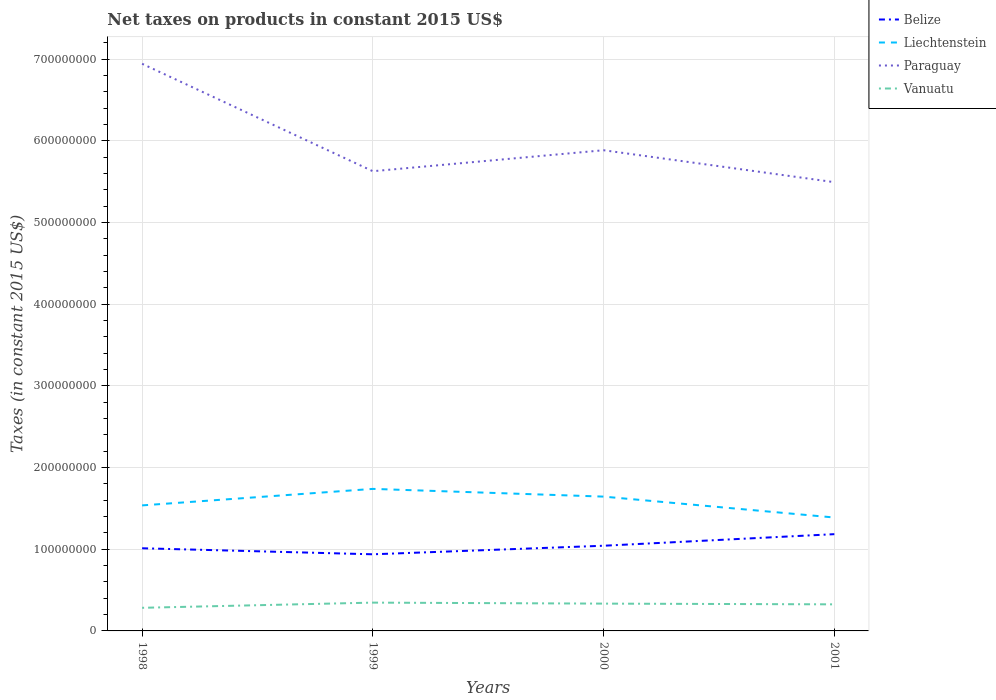How many different coloured lines are there?
Your response must be concise. 4. Is the number of lines equal to the number of legend labels?
Your response must be concise. Yes. Across all years, what is the maximum net taxes on products in Liechtenstein?
Your response must be concise. 1.39e+08. What is the total net taxes on products in Liechtenstein in the graph?
Ensure brevity in your answer.  -1.08e+07. What is the difference between the highest and the second highest net taxes on products in Paraguay?
Keep it short and to the point. 1.45e+08. Are the values on the major ticks of Y-axis written in scientific E-notation?
Keep it short and to the point. No. Does the graph contain any zero values?
Offer a very short reply. No. Where does the legend appear in the graph?
Your answer should be compact. Top right. How many legend labels are there?
Offer a very short reply. 4. How are the legend labels stacked?
Offer a very short reply. Vertical. What is the title of the graph?
Your answer should be very brief. Net taxes on products in constant 2015 US$. What is the label or title of the Y-axis?
Your answer should be compact. Taxes (in constant 2015 US$). What is the Taxes (in constant 2015 US$) in Belize in 1998?
Provide a succinct answer. 1.01e+08. What is the Taxes (in constant 2015 US$) of Liechtenstein in 1998?
Ensure brevity in your answer.  1.54e+08. What is the Taxes (in constant 2015 US$) in Paraguay in 1998?
Your answer should be compact. 6.94e+08. What is the Taxes (in constant 2015 US$) of Vanuatu in 1998?
Provide a short and direct response. 2.83e+07. What is the Taxes (in constant 2015 US$) of Belize in 1999?
Offer a very short reply. 9.38e+07. What is the Taxes (in constant 2015 US$) of Liechtenstein in 1999?
Offer a terse response. 1.74e+08. What is the Taxes (in constant 2015 US$) of Paraguay in 1999?
Provide a short and direct response. 5.63e+08. What is the Taxes (in constant 2015 US$) in Vanuatu in 1999?
Offer a terse response. 3.46e+07. What is the Taxes (in constant 2015 US$) of Belize in 2000?
Give a very brief answer. 1.04e+08. What is the Taxes (in constant 2015 US$) of Liechtenstein in 2000?
Provide a succinct answer. 1.64e+08. What is the Taxes (in constant 2015 US$) of Paraguay in 2000?
Your answer should be very brief. 5.88e+08. What is the Taxes (in constant 2015 US$) in Vanuatu in 2000?
Keep it short and to the point. 3.34e+07. What is the Taxes (in constant 2015 US$) of Belize in 2001?
Provide a short and direct response. 1.18e+08. What is the Taxes (in constant 2015 US$) of Liechtenstein in 2001?
Give a very brief answer. 1.39e+08. What is the Taxes (in constant 2015 US$) in Paraguay in 2001?
Offer a very short reply. 5.49e+08. What is the Taxes (in constant 2015 US$) in Vanuatu in 2001?
Your response must be concise. 3.25e+07. Across all years, what is the maximum Taxes (in constant 2015 US$) in Belize?
Offer a very short reply. 1.18e+08. Across all years, what is the maximum Taxes (in constant 2015 US$) in Liechtenstein?
Your answer should be very brief. 1.74e+08. Across all years, what is the maximum Taxes (in constant 2015 US$) in Paraguay?
Provide a short and direct response. 6.94e+08. Across all years, what is the maximum Taxes (in constant 2015 US$) in Vanuatu?
Provide a short and direct response. 3.46e+07. Across all years, what is the minimum Taxes (in constant 2015 US$) in Belize?
Provide a succinct answer. 9.38e+07. Across all years, what is the minimum Taxes (in constant 2015 US$) of Liechtenstein?
Your response must be concise. 1.39e+08. Across all years, what is the minimum Taxes (in constant 2015 US$) in Paraguay?
Your answer should be compact. 5.49e+08. Across all years, what is the minimum Taxes (in constant 2015 US$) of Vanuatu?
Your answer should be compact. 2.83e+07. What is the total Taxes (in constant 2015 US$) in Belize in the graph?
Provide a short and direct response. 4.18e+08. What is the total Taxes (in constant 2015 US$) in Liechtenstein in the graph?
Make the answer very short. 6.31e+08. What is the total Taxes (in constant 2015 US$) of Paraguay in the graph?
Keep it short and to the point. 2.39e+09. What is the total Taxes (in constant 2015 US$) in Vanuatu in the graph?
Your answer should be very brief. 1.29e+08. What is the difference between the Taxes (in constant 2015 US$) of Belize in 1998 and that in 1999?
Offer a very short reply. 7.38e+06. What is the difference between the Taxes (in constant 2015 US$) of Liechtenstein in 1998 and that in 1999?
Give a very brief answer. -2.02e+07. What is the difference between the Taxes (in constant 2015 US$) in Paraguay in 1998 and that in 1999?
Your answer should be very brief. 1.32e+08. What is the difference between the Taxes (in constant 2015 US$) in Vanuatu in 1998 and that in 1999?
Keep it short and to the point. -6.34e+06. What is the difference between the Taxes (in constant 2015 US$) of Belize in 1998 and that in 2000?
Offer a terse response. -3.10e+06. What is the difference between the Taxes (in constant 2015 US$) in Liechtenstein in 1998 and that in 2000?
Your response must be concise. -1.08e+07. What is the difference between the Taxes (in constant 2015 US$) in Paraguay in 1998 and that in 2000?
Your response must be concise. 1.06e+08. What is the difference between the Taxes (in constant 2015 US$) of Vanuatu in 1998 and that in 2000?
Give a very brief answer. -5.12e+06. What is the difference between the Taxes (in constant 2015 US$) of Belize in 1998 and that in 2001?
Make the answer very short. -1.73e+07. What is the difference between the Taxes (in constant 2015 US$) of Liechtenstein in 1998 and that in 2001?
Provide a short and direct response. 1.48e+07. What is the difference between the Taxes (in constant 2015 US$) in Paraguay in 1998 and that in 2001?
Give a very brief answer. 1.45e+08. What is the difference between the Taxes (in constant 2015 US$) in Vanuatu in 1998 and that in 2001?
Make the answer very short. -4.23e+06. What is the difference between the Taxes (in constant 2015 US$) in Belize in 1999 and that in 2000?
Provide a succinct answer. -1.05e+07. What is the difference between the Taxes (in constant 2015 US$) in Liechtenstein in 1999 and that in 2000?
Make the answer very short. 9.45e+06. What is the difference between the Taxes (in constant 2015 US$) in Paraguay in 1999 and that in 2000?
Your answer should be compact. -2.57e+07. What is the difference between the Taxes (in constant 2015 US$) of Vanuatu in 1999 and that in 2000?
Make the answer very short. 1.22e+06. What is the difference between the Taxes (in constant 2015 US$) of Belize in 1999 and that in 2001?
Offer a terse response. -2.46e+07. What is the difference between the Taxes (in constant 2015 US$) in Liechtenstein in 1999 and that in 2001?
Your response must be concise. 3.50e+07. What is the difference between the Taxes (in constant 2015 US$) of Paraguay in 1999 and that in 2001?
Keep it short and to the point. 1.34e+07. What is the difference between the Taxes (in constant 2015 US$) of Vanuatu in 1999 and that in 2001?
Keep it short and to the point. 2.12e+06. What is the difference between the Taxes (in constant 2015 US$) of Belize in 2000 and that in 2001?
Provide a succinct answer. -1.42e+07. What is the difference between the Taxes (in constant 2015 US$) of Liechtenstein in 2000 and that in 2001?
Ensure brevity in your answer.  2.56e+07. What is the difference between the Taxes (in constant 2015 US$) in Paraguay in 2000 and that in 2001?
Provide a short and direct response. 3.91e+07. What is the difference between the Taxes (in constant 2015 US$) in Vanuatu in 2000 and that in 2001?
Provide a succinct answer. 8.97e+05. What is the difference between the Taxes (in constant 2015 US$) in Belize in 1998 and the Taxes (in constant 2015 US$) in Liechtenstein in 1999?
Your response must be concise. -7.27e+07. What is the difference between the Taxes (in constant 2015 US$) of Belize in 1998 and the Taxes (in constant 2015 US$) of Paraguay in 1999?
Your response must be concise. -4.62e+08. What is the difference between the Taxes (in constant 2015 US$) in Belize in 1998 and the Taxes (in constant 2015 US$) in Vanuatu in 1999?
Ensure brevity in your answer.  6.65e+07. What is the difference between the Taxes (in constant 2015 US$) in Liechtenstein in 1998 and the Taxes (in constant 2015 US$) in Paraguay in 1999?
Keep it short and to the point. -4.09e+08. What is the difference between the Taxes (in constant 2015 US$) of Liechtenstein in 1998 and the Taxes (in constant 2015 US$) of Vanuatu in 1999?
Keep it short and to the point. 1.19e+08. What is the difference between the Taxes (in constant 2015 US$) of Paraguay in 1998 and the Taxes (in constant 2015 US$) of Vanuatu in 1999?
Provide a succinct answer. 6.60e+08. What is the difference between the Taxes (in constant 2015 US$) in Belize in 1998 and the Taxes (in constant 2015 US$) in Liechtenstein in 2000?
Offer a very short reply. -6.32e+07. What is the difference between the Taxes (in constant 2015 US$) of Belize in 1998 and the Taxes (in constant 2015 US$) of Paraguay in 2000?
Ensure brevity in your answer.  -4.87e+08. What is the difference between the Taxes (in constant 2015 US$) of Belize in 1998 and the Taxes (in constant 2015 US$) of Vanuatu in 2000?
Make the answer very short. 6.78e+07. What is the difference between the Taxes (in constant 2015 US$) of Liechtenstein in 1998 and the Taxes (in constant 2015 US$) of Paraguay in 2000?
Your response must be concise. -4.35e+08. What is the difference between the Taxes (in constant 2015 US$) of Liechtenstein in 1998 and the Taxes (in constant 2015 US$) of Vanuatu in 2000?
Your response must be concise. 1.20e+08. What is the difference between the Taxes (in constant 2015 US$) in Paraguay in 1998 and the Taxes (in constant 2015 US$) in Vanuatu in 2000?
Ensure brevity in your answer.  6.61e+08. What is the difference between the Taxes (in constant 2015 US$) in Belize in 1998 and the Taxes (in constant 2015 US$) in Liechtenstein in 2001?
Offer a terse response. -3.76e+07. What is the difference between the Taxes (in constant 2015 US$) in Belize in 1998 and the Taxes (in constant 2015 US$) in Paraguay in 2001?
Your answer should be very brief. -4.48e+08. What is the difference between the Taxes (in constant 2015 US$) of Belize in 1998 and the Taxes (in constant 2015 US$) of Vanuatu in 2001?
Ensure brevity in your answer.  6.87e+07. What is the difference between the Taxes (in constant 2015 US$) of Liechtenstein in 1998 and the Taxes (in constant 2015 US$) of Paraguay in 2001?
Your response must be concise. -3.96e+08. What is the difference between the Taxes (in constant 2015 US$) of Liechtenstein in 1998 and the Taxes (in constant 2015 US$) of Vanuatu in 2001?
Provide a short and direct response. 1.21e+08. What is the difference between the Taxes (in constant 2015 US$) in Paraguay in 1998 and the Taxes (in constant 2015 US$) in Vanuatu in 2001?
Your answer should be very brief. 6.62e+08. What is the difference between the Taxes (in constant 2015 US$) of Belize in 1999 and the Taxes (in constant 2015 US$) of Liechtenstein in 2000?
Your answer should be very brief. -7.06e+07. What is the difference between the Taxes (in constant 2015 US$) in Belize in 1999 and the Taxes (in constant 2015 US$) in Paraguay in 2000?
Offer a terse response. -4.95e+08. What is the difference between the Taxes (in constant 2015 US$) in Belize in 1999 and the Taxes (in constant 2015 US$) in Vanuatu in 2000?
Make the answer very short. 6.04e+07. What is the difference between the Taxes (in constant 2015 US$) in Liechtenstein in 1999 and the Taxes (in constant 2015 US$) in Paraguay in 2000?
Ensure brevity in your answer.  -4.15e+08. What is the difference between the Taxes (in constant 2015 US$) in Liechtenstein in 1999 and the Taxes (in constant 2015 US$) in Vanuatu in 2000?
Provide a short and direct response. 1.40e+08. What is the difference between the Taxes (in constant 2015 US$) in Paraguay in 1999 and the Taxes (in constant 2015 US$) in Vanuatu in 2000?
Provide a short and direct response. 5.29e+08. What is the difference between the Taxes (in constant 2015 US$) in Belize in 1999 and the Taxes (in constant 2015 US$) in Liechtenstein in 2001?
Keep it short and to the point. -4.50e+07. What is the difference between the Taxes (in constant 2015 US$) in Belize in 1999 and the Taxes (in constant 2015 US$) in Paraguay in 2001?
Keep it short and to the point. -4.56e+08. What is the difference between the Taxes (in constant 2015 US$) of Belize in 1999 and the Taxes (in constant 2015 US$) of Vanuatu in 2001?
Keep it short and to the point. 6.13e+07. What is the difference between the Taxes (in constant 2015 US$) of Liechtenstein in 1999 and the Taxes (in constant 2015 US$) of Paraguay in 2001?
Give a very brief answer. -3.75e+08. What is the difference between the Taxes (in constant 2015 US$) of Liechtenstein in 1999 and the Taxes (in constant 2015 US$) of Vanuatu in 2001?
Your answer should be very brief. 1.41e+08. What is the difference between the Taxes (in constant 2015 US$) in Paraguay in 1999 and the Taxes (in constant 2015 US$) in Vanuatu in 2001?
Make the answer very short. 5.30e+08. What is the difference between the Taxes (in constant 2015 US$) of Belize in 2000 and the Taxes (in constant 2015 US$) of Liechtenstein in 2001?
Ensure brevity in your answer.  -3.45e+07. What is the difference between the Taxes (in constant 2015 US$) in Belize in 2000 and the Taxes (in constant 2015 US$) in Paraguay in 2001?
Give a very brief answer. -4.45e+08. What is the difference between the Taxes (in constant 2015 US$) of Belize in 2000 and the Taxes (in constant 2015 US$) of Vanuatu in 2001?
Ensure brevity in your answer.  7.18e+07. What is the difference between the Taxes (in constant 2015 US$) of Liechtenstein in 2000 and the Taxes (in constant 2015 US$) of Paraguay in 2001?
Your response must be concise. -3.85e+08. What is the difference between the Taxes (in constant 2015 US$) of Liechtenstein in 2000 and the Taxes (in constant 2015 US$) of Vanuatu in 2001?
Keep it short and to the point. 1.32e+08. What is the difference between the Taxes (in constant 2015 US$) of Paraguay in 2000 and the Taxes (in constant 2015 US$) of Vanuatu in 2001?
Your response must be concise. 5.56e+08. What is the average Taxes (in constant 2015 US$) of Belize per year?
Ensure brevity in your answer.  1.04e+08. What is the average Taxes (in constant 2015 US$) in Liechtenstein per year?
Provide a succinct answer. 1.58e+08. What is the average Taxes (in constant 2015 US$) of Paraguay per year?
Provide a succinct answer. 5.99e+08. What is the average Taxes (in constant 2015 US$) in Vanuatu per year?
Give a very brief answer. 3.22e+07. In the year 1998, what is the difference between the Taxes (in constant 2015 US$) in Belize and Taxes (in constant 2015 US$) in Liechtenstein?
Offer a very short reply. -5.25e+07. In the year 1998, what is the difference between the Taxes (in constant 2015 US$) in Belize and Taxes (in constant 2015 US$) in Paraguay?
Your answer should be compact. -5.93e+08. In the year 1998, what is the difference between the Taxes (in constant 2015 US$) in Belize and Taxes (in constant 2015 US$) in Vanuatu?
Give a very brief answer. 7.29e+07. In the year 1998, what is the difference between the Taxes (in constant 2015 US$) of Liechtenstein and Taxes (in constant 2015 US$) of Paraguay?
Provide a succinct answer. -5.41e+08. In the year 1998, what is the difference between the Taxes (in constant 2015 US$) of Liechtenstein and Taxes (in constant 2015 US$) of Vanuatu?
Provide a short and direct response. 1.25e+08. In the year 1998, what is the difference between the Taxes (in constant 2015 US$) of Paraguay and Taxes (in constant 2015 US$) of Vanuatu?
Your answer should be compact. 6.66e+08. In the year 1999, what is the difference between the Taxes (in constant 2015 US$) of Belize and Taxes (in constant 2015 US$) of Liechtenstein?
Your answer should be compact. -8.01e+07. In the year 1999, what is the difference between the Taxes (in constant 2015 US$) of Belize and Taxes (in constant 2015 US$) of Paraguay?
Make the answer very short. -4.69e+08. In the year 1999, what is the difference between the Taxes (in constant 2015 US$) in Belize and Taxes (in constant 2015 US$) in Vanuatu?
Your response must be concise. 5.92e+07. In the year 1999, what is the difference between the Taxes (in constant 2015 US$) of Liechtenstein and Taxes (in constant 2015 US$) of Paraguay?
Your answer should be compact. -3.89e+08. In the year 1999, what is the difference between the Taxes (in constant 2015 US$) of Liechtenstein and Taxes (in constant 2015 US$) of Vanuatu?
Offer a very short reply. 1.39e+08. In the year 1999, what is the difference between the Taxes (in constant 2015 US$) in Paraguay and Taxes (in constant 2015 US$) in Vanuatu?
Give a very brief answer. 5.28e+08. In the year 2000, what is the difference between the Taxes (in constant 2015 US$) in Belize and Taxes (in constant 2015 US$) in Liechtenstein?
Ensure brevity in your answer.  -6.01e+07. In the year 2000, what is the difference between the Taxes (in constant 2015 US$) in Belize and Taxes (in constant 2015 US$) in Paraguay?
Offer a terse response. -4.84e+08. In the year 2000, what is the difference between the Taxes (in constant 2015 US$) of Belize and Taxes (in constant 2015 US$) of Vanuatu?
Provide a succinct answer. 7.09e+07. In the year 2000, what is the difference between the Taxes (in constant 2015 US$) in Liechtenstein and Taxes (in constant 2015 US$) in Paraguay?
Keep it short and to the point. -4.24e+08. In the year 2000, what is the difference between the Taxes (in constant 2015 US$) in Liechtenstein and Taxes (in constant 2015 US$) in Vanuatu?
Give a very brief answer. 1.31e+08. In the year 2000, what is the difference between the Taxes (in constant 2015 US$) of Paraguay and Taxes (in constant 2015 US$) of Vanuatu?
Offer a very short reply. 5.55e+08. In the year 2001, what is the difference between the Taxes (in constant 2015 US$) of Belize and Taxes (in constant 2015 US$) of Liechtenstein?
Provide a succinct answer. -2.04e+07. In the year 2001, what is the difference between the Taxes (in constant 2015 US$) in Belize and Taxes (in constant 2015 US$) in Paraguay?
Your answer should be very brief. -4.31e+08. In the year 2001, what is the difference between the Taxes (in constant 2015 US$) of Belize and Taxes (in constant 2015 US$) of Vanuatu?
Offer a terse response. 8.59e+07. In the year 2001, what is the difference between the Taxes (in constant 2015 US$) of Liechtenstein and Taxes (in constant 2015 US$) of Paraguay?
Provide a short and direct response. -4.11e+08. In the year 2001, what is the difference between the Taxes (in constant 2015 US$) of Liechtenstein and Taxes (in constant 2015 US$) of Vanuatu?
Your answer should be compact. 1.06e+08. In the year 2001, what is the difference between the Taxes (in constant 2015 US$) of Paraguay and Taxes (in constant 2015 US$) of Vanuatu?
Your answer should be compact. 5.17e+08. What is the ratio of the Taxes (in constant 2015 US$) of Belize in 1998 to that in 1999?
Keep it short and to the point. 1.08. What is the ratio of the Taxes (in constant 2015 US$) in Liechtenstein in 1998 to that in 1999?
Your answer should be very brief. 0.88. What is the ratio of the Taxes (in constant 2015 US$) of Paraguay in 1998 to that in 1999?
Your answer should be compact. 1.23. What is the ratio of the Taxes (in constant 2015 US$) of Vanuatu in 1998 to that in 1999?
Make the answer very short. 0.82. What is the ratio of the Taxes (in constant 2015 US$) in Belize in 1998 to that in 2000?
Keep it short and to the point. 0.97. What is the ratio of the Taxes (in constant 2015 US$) of Liechtenstein in 1998 to that in 2000?
Make the answer very short. 0.93. What is the ratio of the Taxes (in constant 2015 US$) of Paraguay in 1998 to that in 2000?
Offer a very short reply. 1.18. What is the ratio of the Taxes (in constant 2015 US$) in Vanuatu in 1998 to that in 2000?
Make the answer very short. 0.85. What is the ratio of the Taxes (in constant 2015 US$) in Belize in 1998 to that in 2001?
Your answer should be very brief. 0.85. What is the ratio of the Taxes (in constant 2015 US$) in Liechtenstein in 1998 to that in 2001?
Offer a very short reply. 1.11. What is the ratio of the Taxes (in constant 2015 US$) of Paraguay in 1998 to that in 2001?
Ensure brevity in your answer.  1.26. What is the ratio of the Taxes (in constant 2015 US$) in Vanuatu in 1998 to that in 2001?
Your response must be concise. 0.87. What is the ratio of the Taxes (in constant 2015 US$) in Belize in 1999 to that in 2000?
Make the answer very short. 0.9. What is the ratio of the Taxes (in constant 2015 US$) in Liechtenstein in 1999 to that in 2000?
Ensure brevity in your answer.  1.06. What is the ratio of the Taxes (in constant 2015 US$) in Paraguay in 1999 to that in 2000?
Your response must be concise. 0.96. What is the ratio of the Taxes (in constant 2015 US$) of Vanuatu in 1999 to that in 2000?
Provide a succinct answer. 1.04. What is the ratio of the Taxes (in constant 2015 US$) in Belize in 1999 to that in 2001?
Offer a terse response. 0.79. What is the ratio of the Taxes (in constant 2015 US$) of Liechtenstein in 1999 to that in 2001?
Make the answer very short. 1.25. What is the ratio of the Taxes (in constant 2015 US$) in Paraguay in 1999 to that in 2001?
Provide a succinct answer. 1.02. What is the ratio of the Taxes (in constant 2015 US$) of Vanuatu in 1999 to that in 2001?
Your answer should be compact. 1.07. What is the ratio of the Taxes (in constant 2015 US$) of Belize in 2000 to that in 2001?
Ensure brevity in your answer.  0.88. What is the ratio of the Taxes (in constant 2015 US$) in Liechtenstein in 2000 to that in 2001?
Give a very brief answer. 1.18. What is the ratio of the Taxes (in constant 2015 US$) in Paraguay in 2000 to that in 2001?
Offer a terse response. 1.07. What is the ratio of the Taxes (in constant 2015 US$) in Vanuatu in 2000 to that in 2001?
Provide a succinct answer. 1.03. What is the difference between the highest and the second highest Taxes (in constant 2015 US$) in Belize?
Your response must be concise. 1.42e+07. What is the difference between the highest and the second highest Taxes (in constant 2015 US$) of Liechtenstein?
Offer a very short reply. 9.45e+06. What is the difference between the highest and the second highest Taxes (in constant 2015 US$) in Paraguay?
Keep it short and to the point. 1.06e+08. What is the difference between the highest and the second highest Taxes (in constant 2015 US$) of Vanuatu?
Keep it short and to the point. 1.22e+06. What is the difference between the highest and the lowest Taxes (in constant 2015 US$) in Belize?
Your response must be concise. 2.46e+07. What is the difference between the highest and the lowest Taxes (in constant 2015 US$) of Liechtenstein?
Keep it short and to the point. 3.50e+07. What is the difference between the highest and the lowest Taxes (in constant 2015 US$) of Paraguay?
Offer a terse response. 1.45e+08. What is the difference between the highest and the lowest Taxes (in constant 2015 US$) in Vanuatu?
Provide a succinct answer. 6.34e+06. 